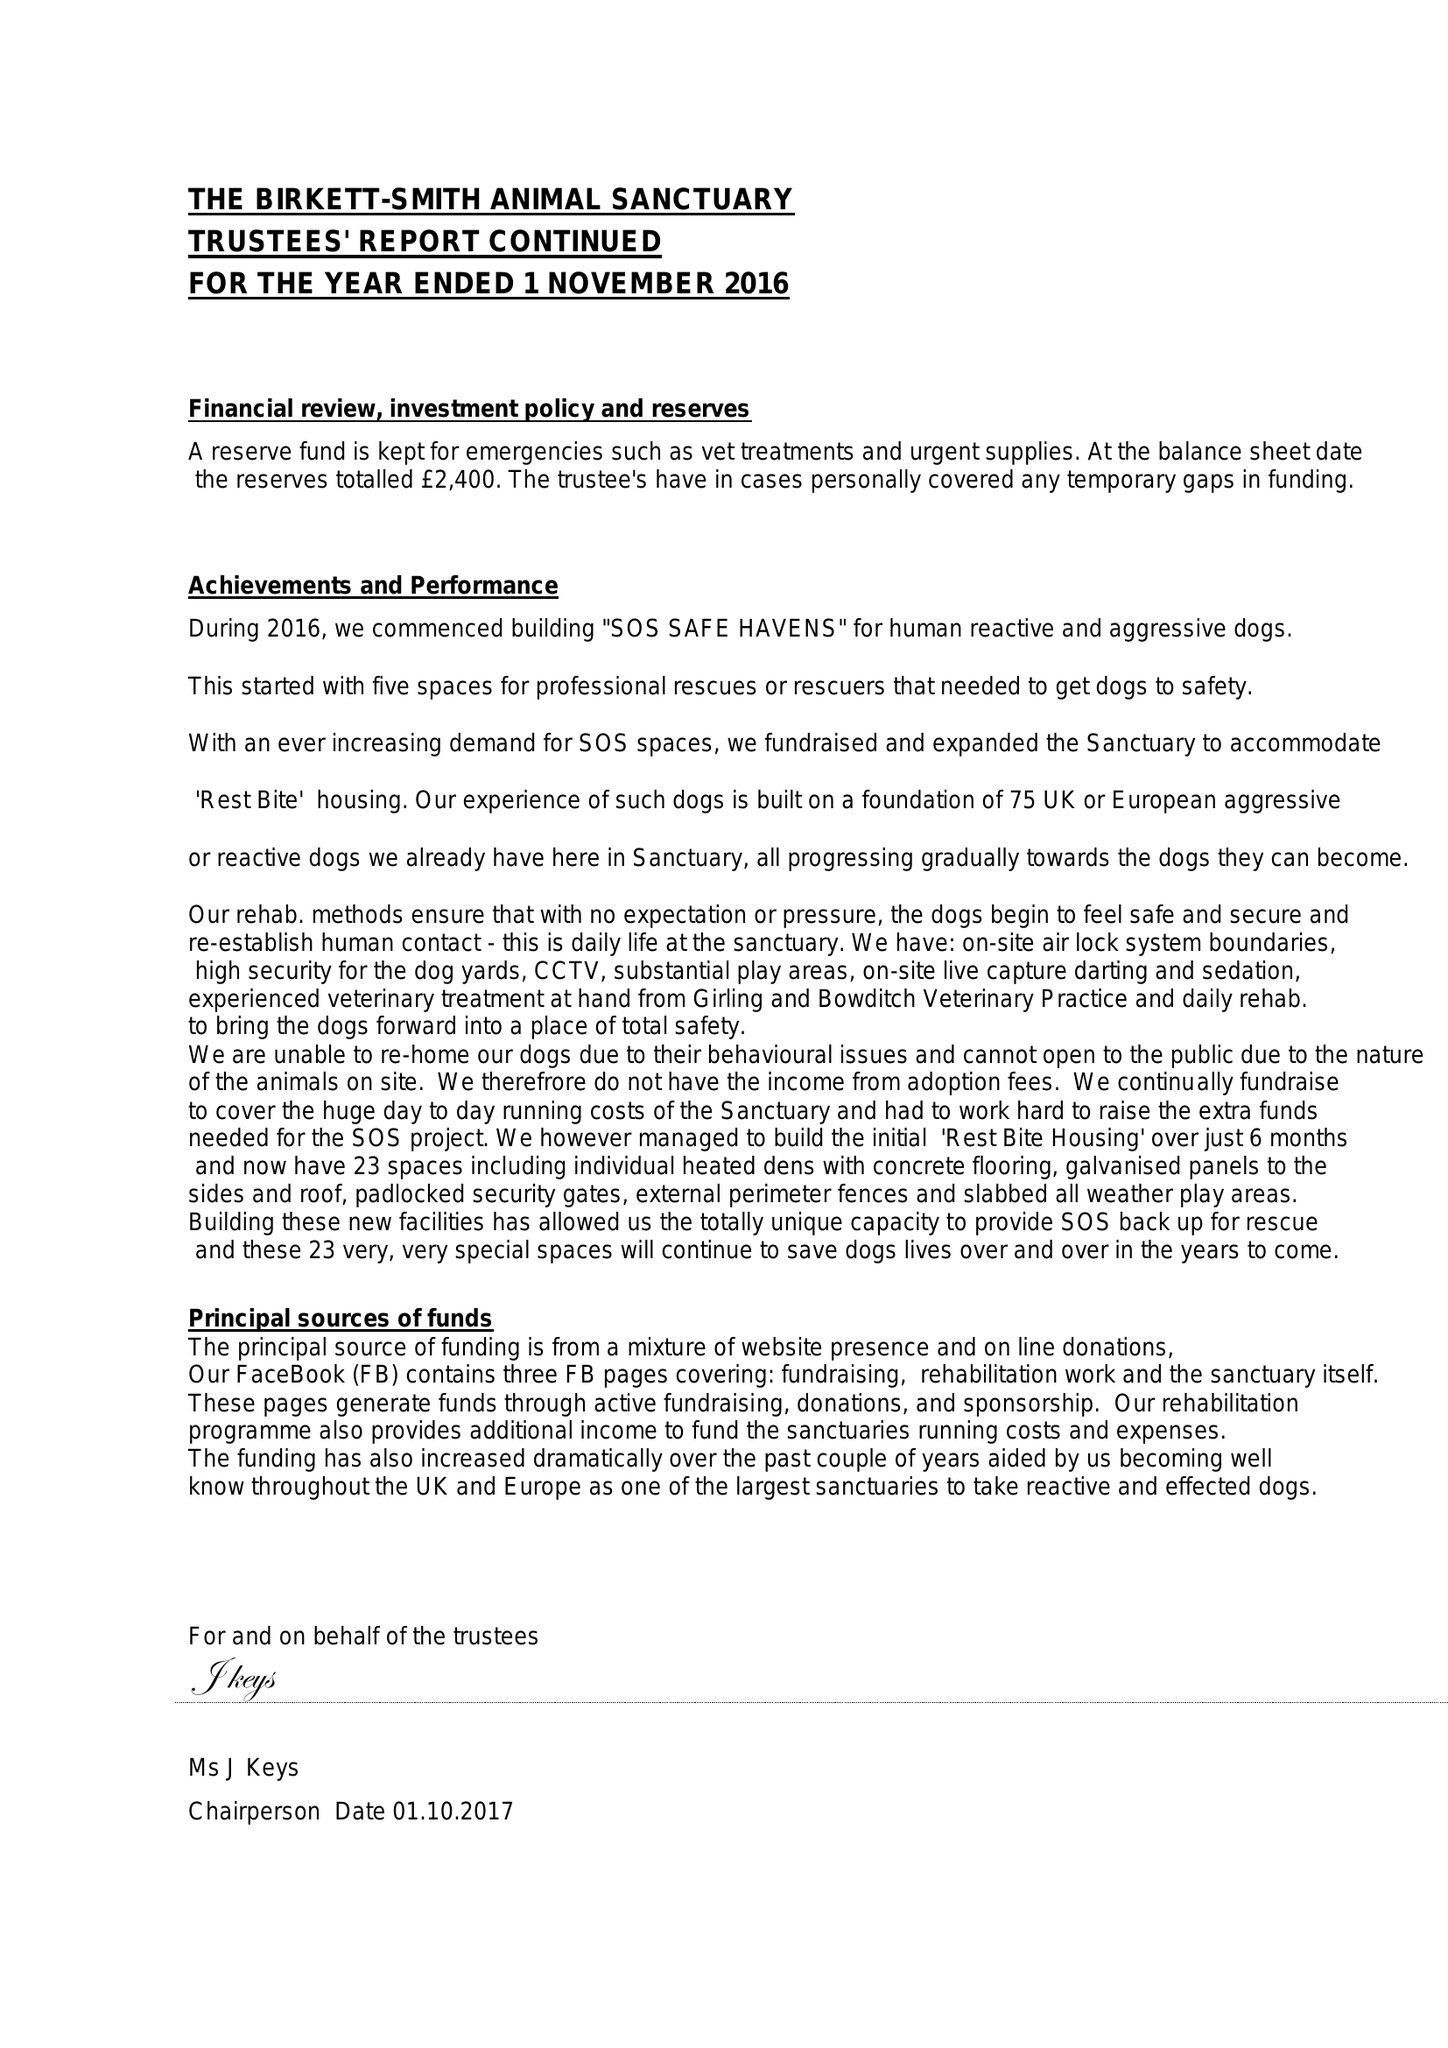What is the value for the report_date?
Answer the question using a single word or phrase. 2016-11-01 